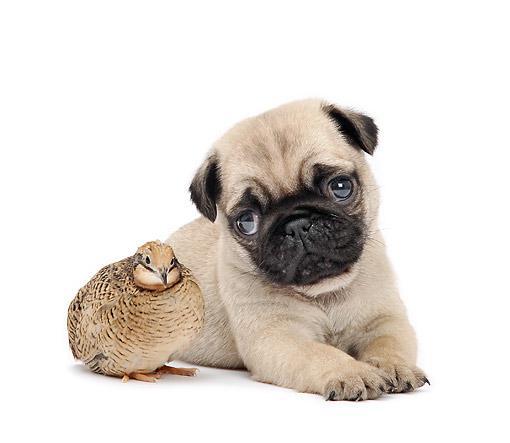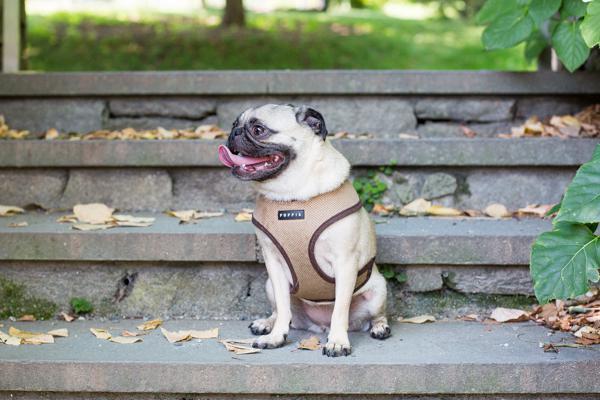The first image is the image on the left, the second image is the image on the right. Examine the images to the left and right. Is the description "The dog in the right image is wearing a harness." accurate? Answer yes or no. Yes. The first image is the image on the left, the second image is the image on the right. Considering the images on both sides, is "There is one bird next to a dog." valid? Answer yes or no. Yes. 